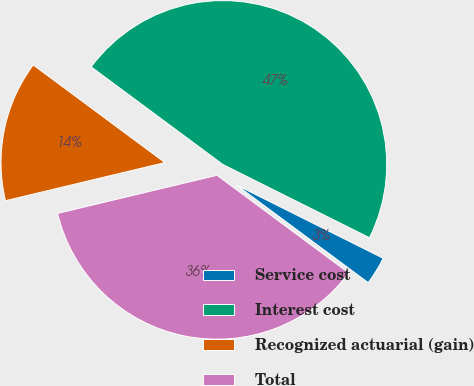<chart> <loc_0><loc_0><loc_500><loc_500><pie_chart><fcel>Service cost<fcel>Interest cost<fcel>Recognized actuarial (gain)<fcel>Total<nl><fcel>2.78%<fcel>47.22%<fcel>13.89%<fcel>36.11%<nl></chart> 